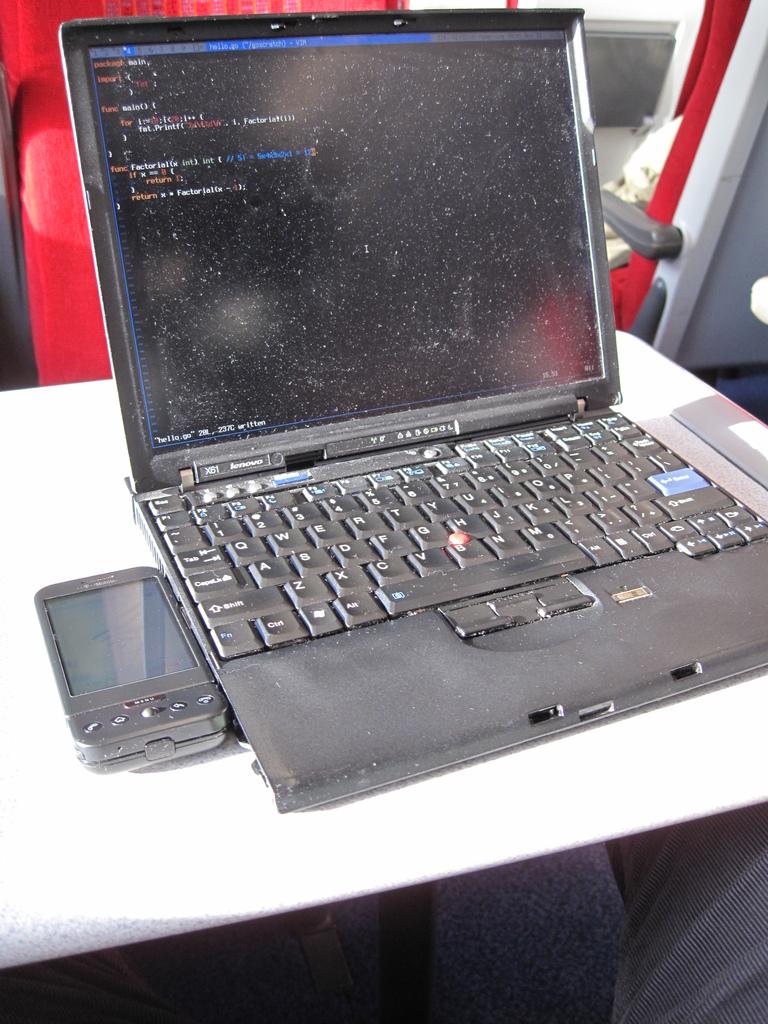What brand of laptop is that?
Provide a short and direct response. Lenovo. 